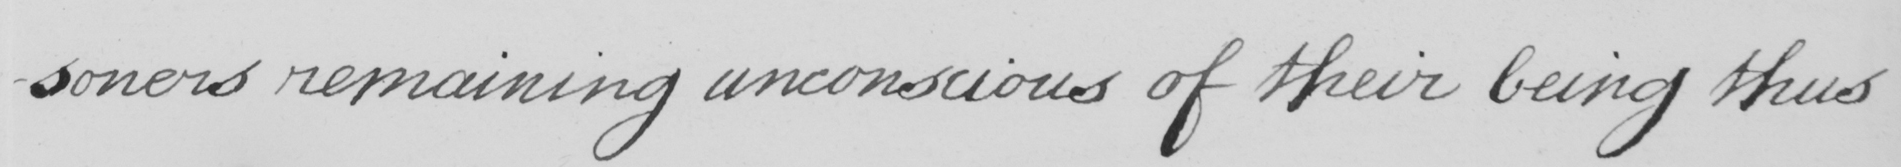Can you tell me what this handwritten text says? -soners remaining unconscious of their being thus 